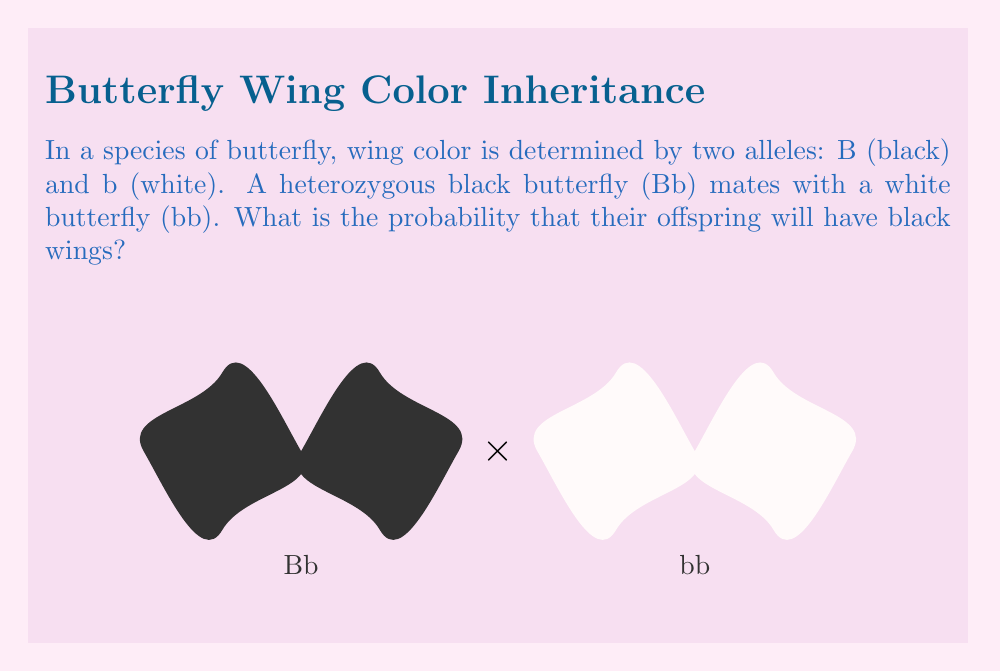Give your solution to this math problem. To solve this problem, we need to use the principles of Mendelian genetics:

1) First, let's identify the genotypes of the parent butterflies:
   - Heterozygous black butterfly: Bb
   - White butterfly: bb

2) Now, let's create a Punnett square to visualize the possible offspring genotypes:

   $$
   \begin{array}{c|c|c}
    & \text{B} & \text{b} \\
   \hline
   \text{b} & \text{Bb} & \text{bb} \\
   \hline
   \text{b} & \text{Bb} & \text{bb}
   \end{array}
   $$

3) From the Punnett square, we can see that:
   - 2 out of 4 possible combinations result in Bb (black wings)
   - 2 out of 4 possible combinations result in bb (white wings)

4) The probability of an offspring having black wings is equal to the number of favorable outcomes divided by the total number of possible outcomes:

   $$P(\text{black wings}) = \frac{\text{number of Bb combinations}}{\text{total number of combinations}} = \frac{2}{4} = \frac{1}{2}$$

5) This can also be expressed as a percentage: $\frac{1}{2} \times 100\% = 50\%$

Therefore, the probability that an offspring from this mating will have black wings is $\frac{1}{2}$ or 50%.
Answer: $\frac{1}{2}$ 